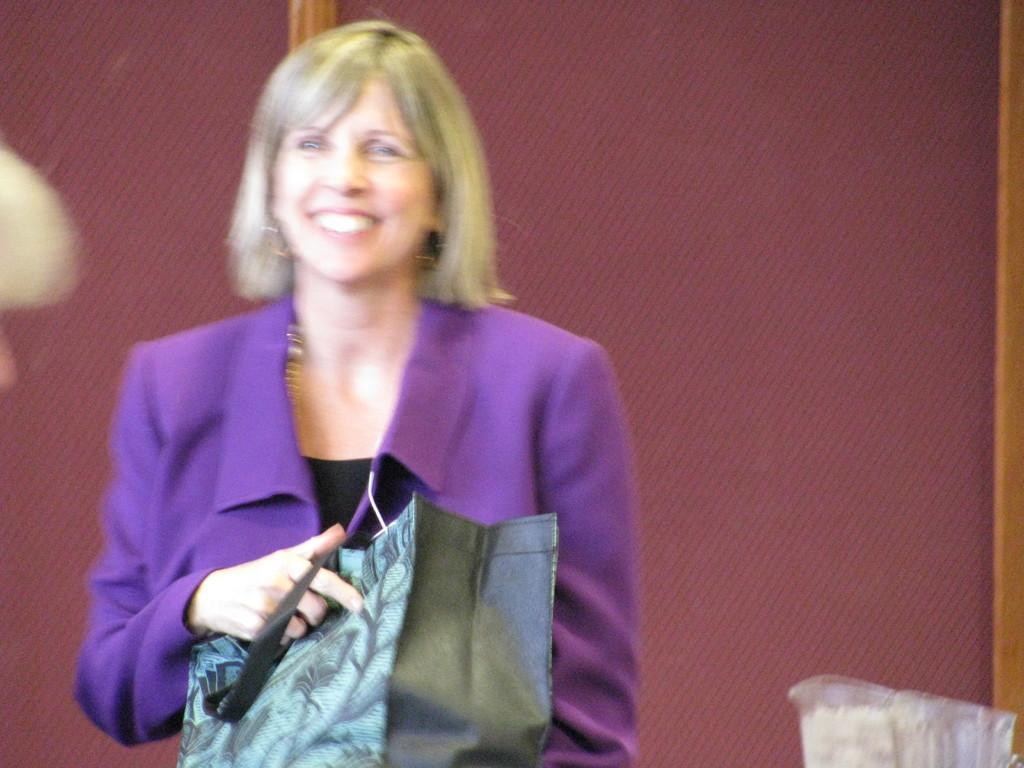Could you give a brief overview of what you see in this image? Towards left there is a woman in violet jacket, holding a bag, she is smiling. On the right there is an object. In the background there is a window which is red in color. 